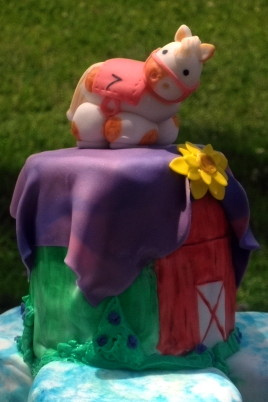<image>What type of stuffed animal is it? I am not sure. It can be seen a pig, a horse, or a pony. What kind of toy is this? I don't know what kind of toy this is. The answers vary between a stuffed animal, pony, barn, cow, cake, playhouse, and play doh. What type of stuffed animal is it? I am not sure what type of stuffed animal it is. It can be seen as a pig, horse or pony. What kind of toy is this? It is unknown what kind of toy this is. It can be seen as a stuffed animal, a pony, or a playhouse. 